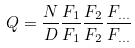Convert formula to latex. <formula><loc_0><loc_0><loc_500><loc_500>Q = \frac { N } { D } \frac { F _ { 1 } } { F _ { 1 } } \frac { F _ { 2 } } { F _ { 2 } } \frac { F _ { \dots } } { F _ { \dots } }</formula> 